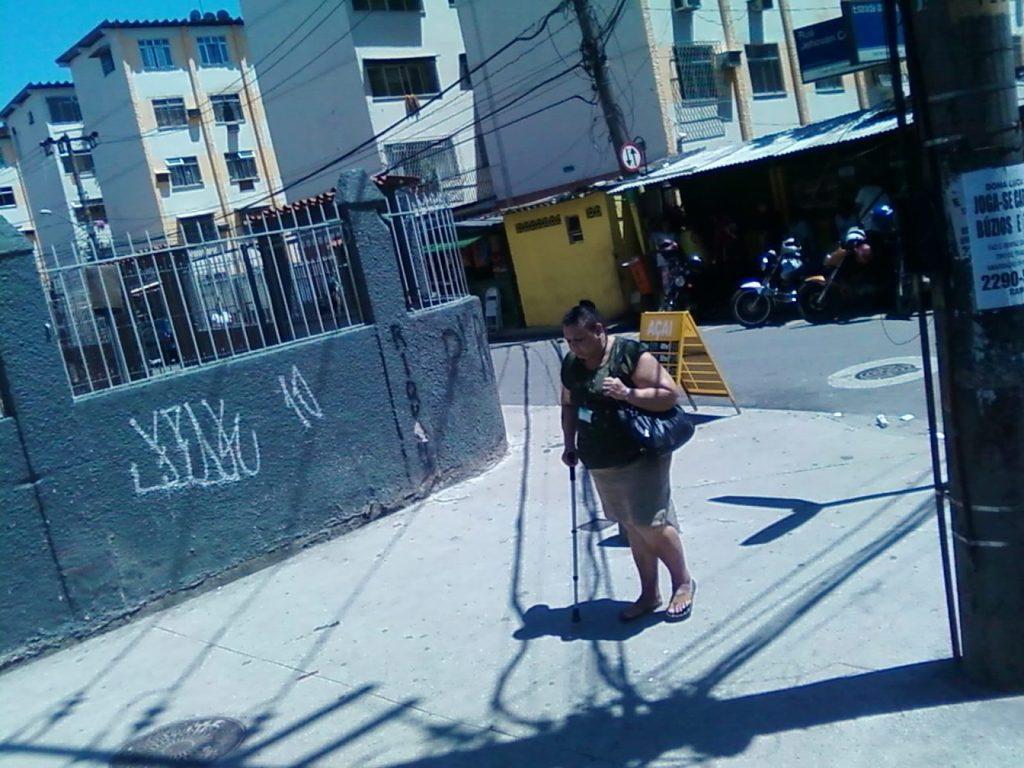How would you summarize this image in a sentence or two? In this image there is the sky, there are buildings, there is a building truncated towards the left of the image, there are poles, there are wires, there is a wall truncated towards the left of the image, there is a road, there are vehicles on the road, there are boards, there is an object on the ground, there is a person holding an object, there is a person wearing a bag, there is a pole truncated towards the right of the image, there is a paper on the pole, there is a paper truncated towards the left of the image, there is text on the paper. 